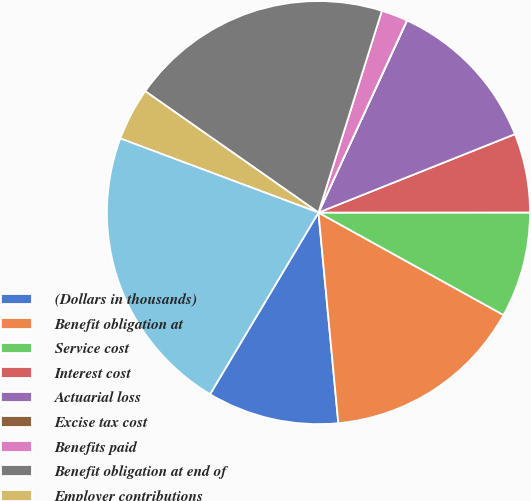<chart> <loc_0><loc_0><loc_500><loc_500><pie_chart><fcel>(Dollars in thousands)<fcel>Benefit obligation at<fcel>Service cost<fcel>Interest cost<fcel>Actuarial loss<fcel>Excise tax cost<fcel>Benefits paid<fcel>Benefit obligation at end of<fcel>Employer contributions<fcel>Funded status at end of year<nl><fcel>10.06%<fcel>15.46%<fcel>8.05%<fcel>6.04%<fcel>12.08%<fcel>0.01%<fcel>2.02%<fcel>20.12%<fcel>4.03%<fcel>22.13%<nl></chart> 